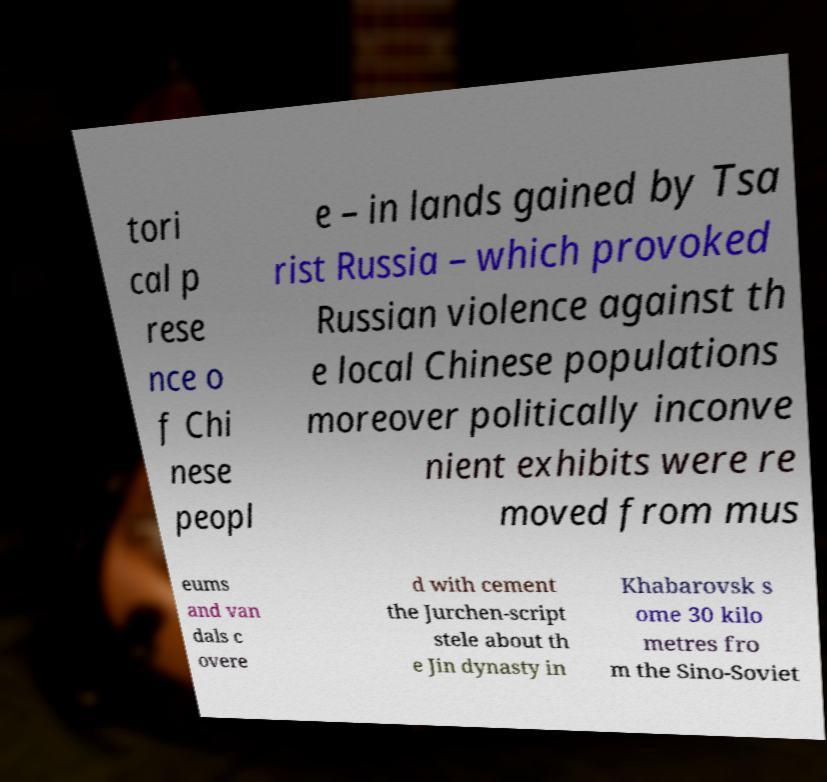Could you extract and type out the text from this image? tori cal p rese nce o f Chi nese peopl e – in lands gained by Tsa rist Russia – which provoked Russian violence against th e local Chinese populations moreover politically inconve nient exhibits were re moved from mus eums and van dals c overe d with cement the Jurchen-script stele about th e Jin dynasty in Khabarovsk s ome 30 kilo metres fro m the Sino-Soviet 